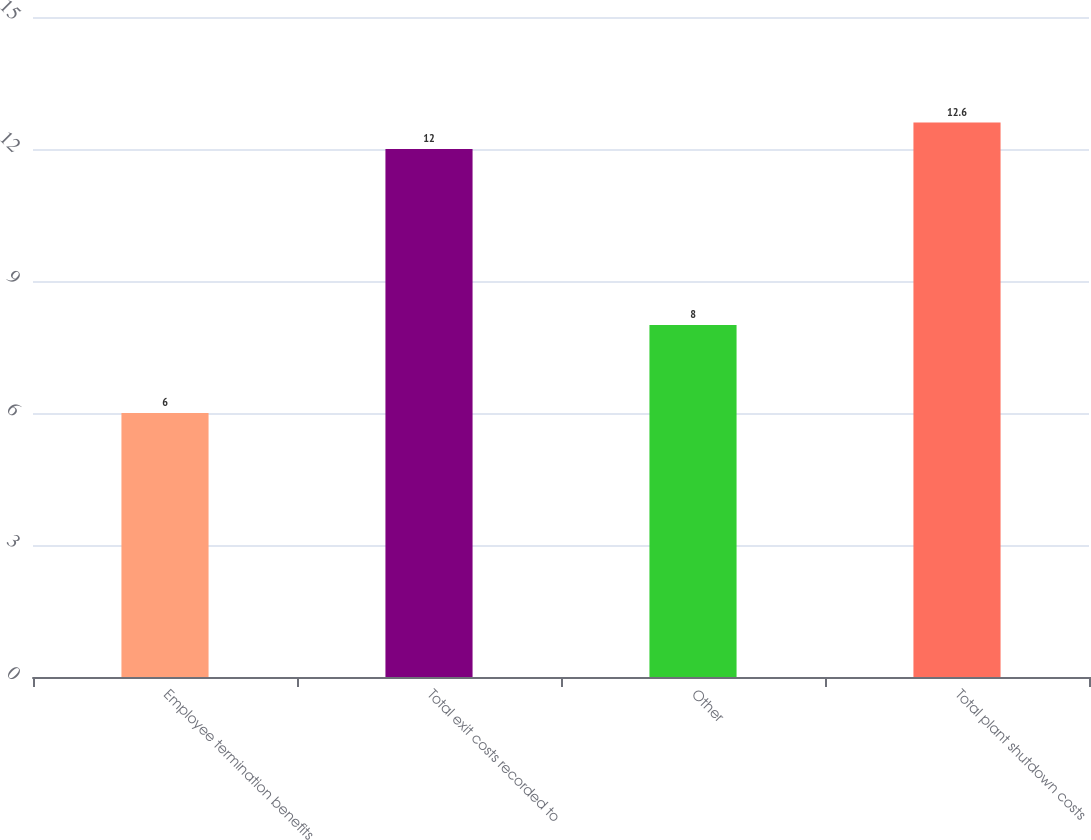<chart> <loc_0><loc_0><loc_500><loc_500><bar_chart><fcel>Employee termination benefits<fcel>Total exit costs recorded to<fcel>Other<fcel>Total plant shutdown costs<nl><fcel>6<fcel>12<fcel>8<fcel>12.6<nl></chart> 